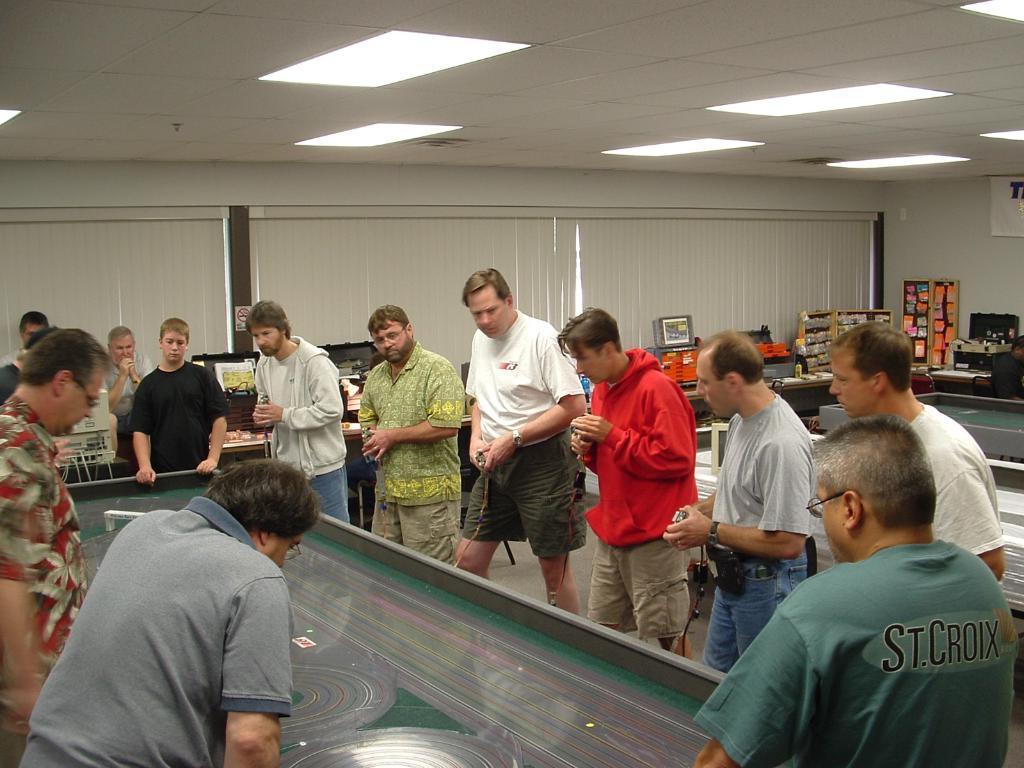Describe this image in one or two sentences. There are group of men in a room. All of them are staring and standing besides a table. The room consists of lights, curtains, desk. 